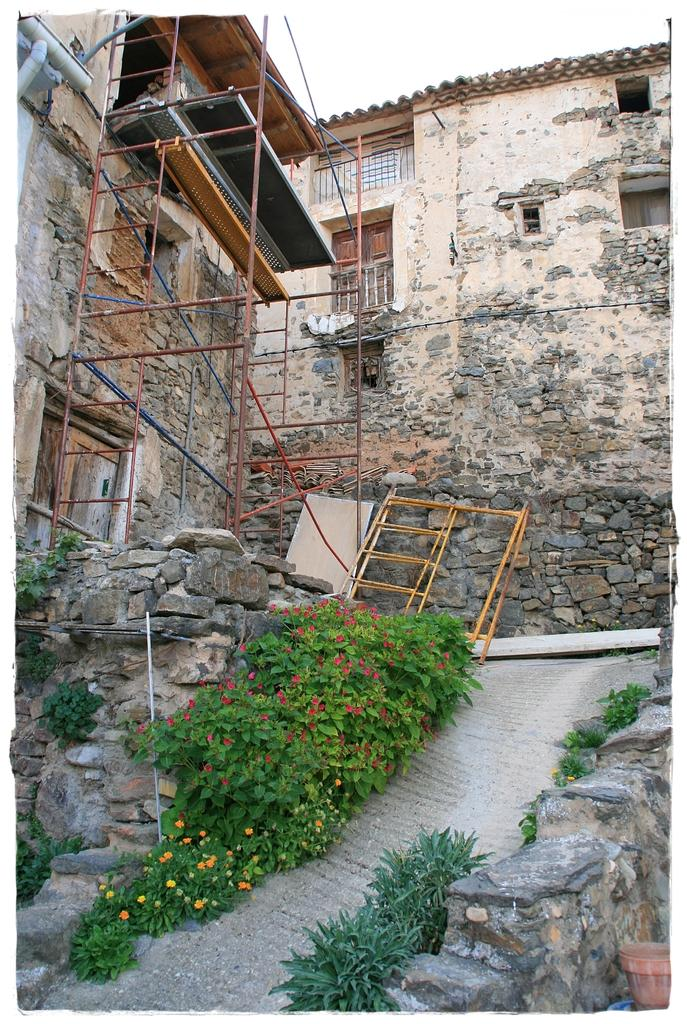What type of plants can be seen in the image? There are flowering plants in the image. What type of fence is present in the image? There is a stone fence in the image. What material are the rods made of in the image? The rods in the image are made of metal. What structures can be seen in the image? A: There are buildings in the image. What part of the natural environment is visible in the image? The sky is visible in the image. Can you determine the time of day the image was taken? The image was likely taken during the day, as the sky is visible and there is no indication of darkness. Can you see a boat floating in the sky in the image? No, there is no boat visible in the image. What type of twig is being used to hold up the metal rods in the image? There are no twigs present in the image; the metal rods are not being held up by any visible support. 